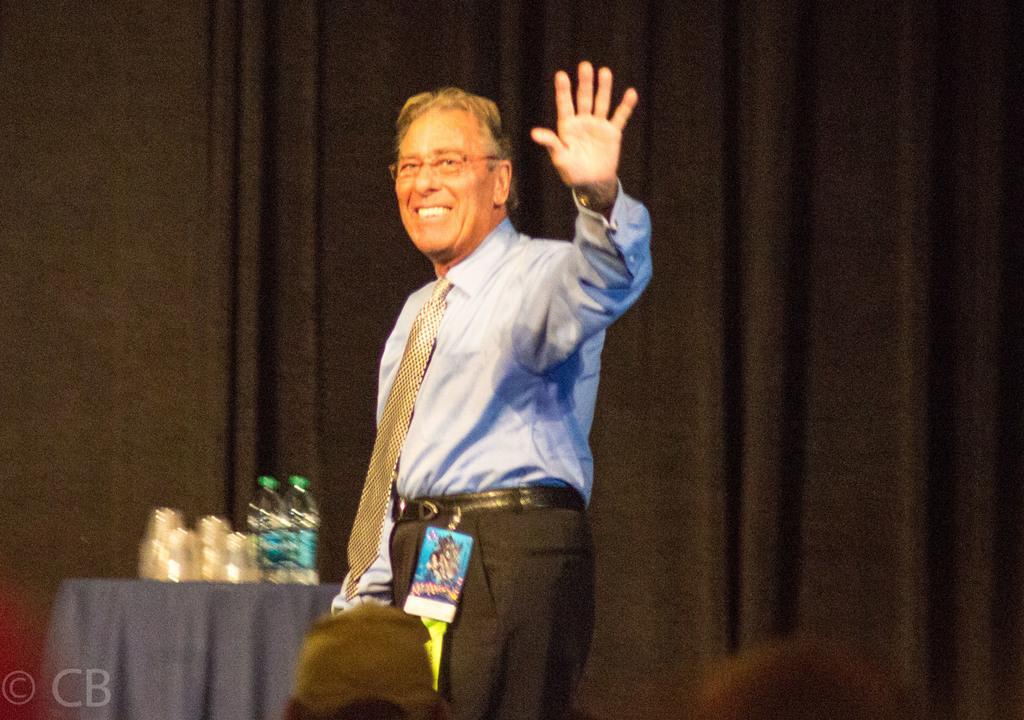Please provide a concise description of this image. In the middle of this image, there is a person in a blue color shirt, wearing a spectacle, smiling and showing a hand. In the background, there are bottles and other objects arranged on the table, which is covered with violet color cloth, there is a curtain and there is a wall. 